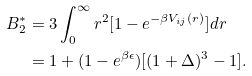<formula> <loc_0><loc_0><loc_500><loc_500>B _ { 2 } ^ { * } & = 3 \int _ { 0 } ^ { \infty } r ^ { 2 } [ 1 - e ^ { - \beta V _ { i j } ( r ) } ] d r \\ & = 1 + ( 1 - e ^ { \beta \epsilon } ) [ ( 1 + \Delta ) ^ { 3 } - 1 ] .</formula> 